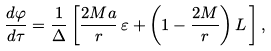<formula> <loc_0><loc_0><loc_500><loc_500>\frac { d \varphi } { d \tau } = \frac { 1 } { \Delta } \left [ \frac { 2 M a } { r } \, \varepsilon + \left ( 1 - \frac { 2 M } { r } \right ) L \, \right ] ,</formula> 